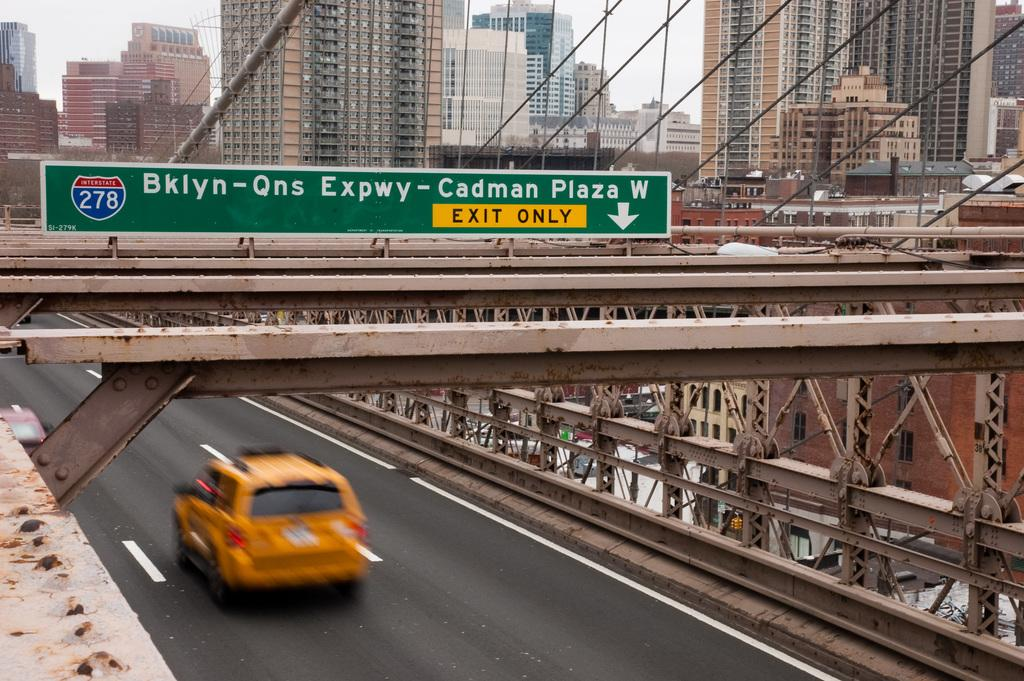<image>
Relay a brief, clear account of the picture shown. A sign over a highway that read EXIT ONLY in the yellow section. 